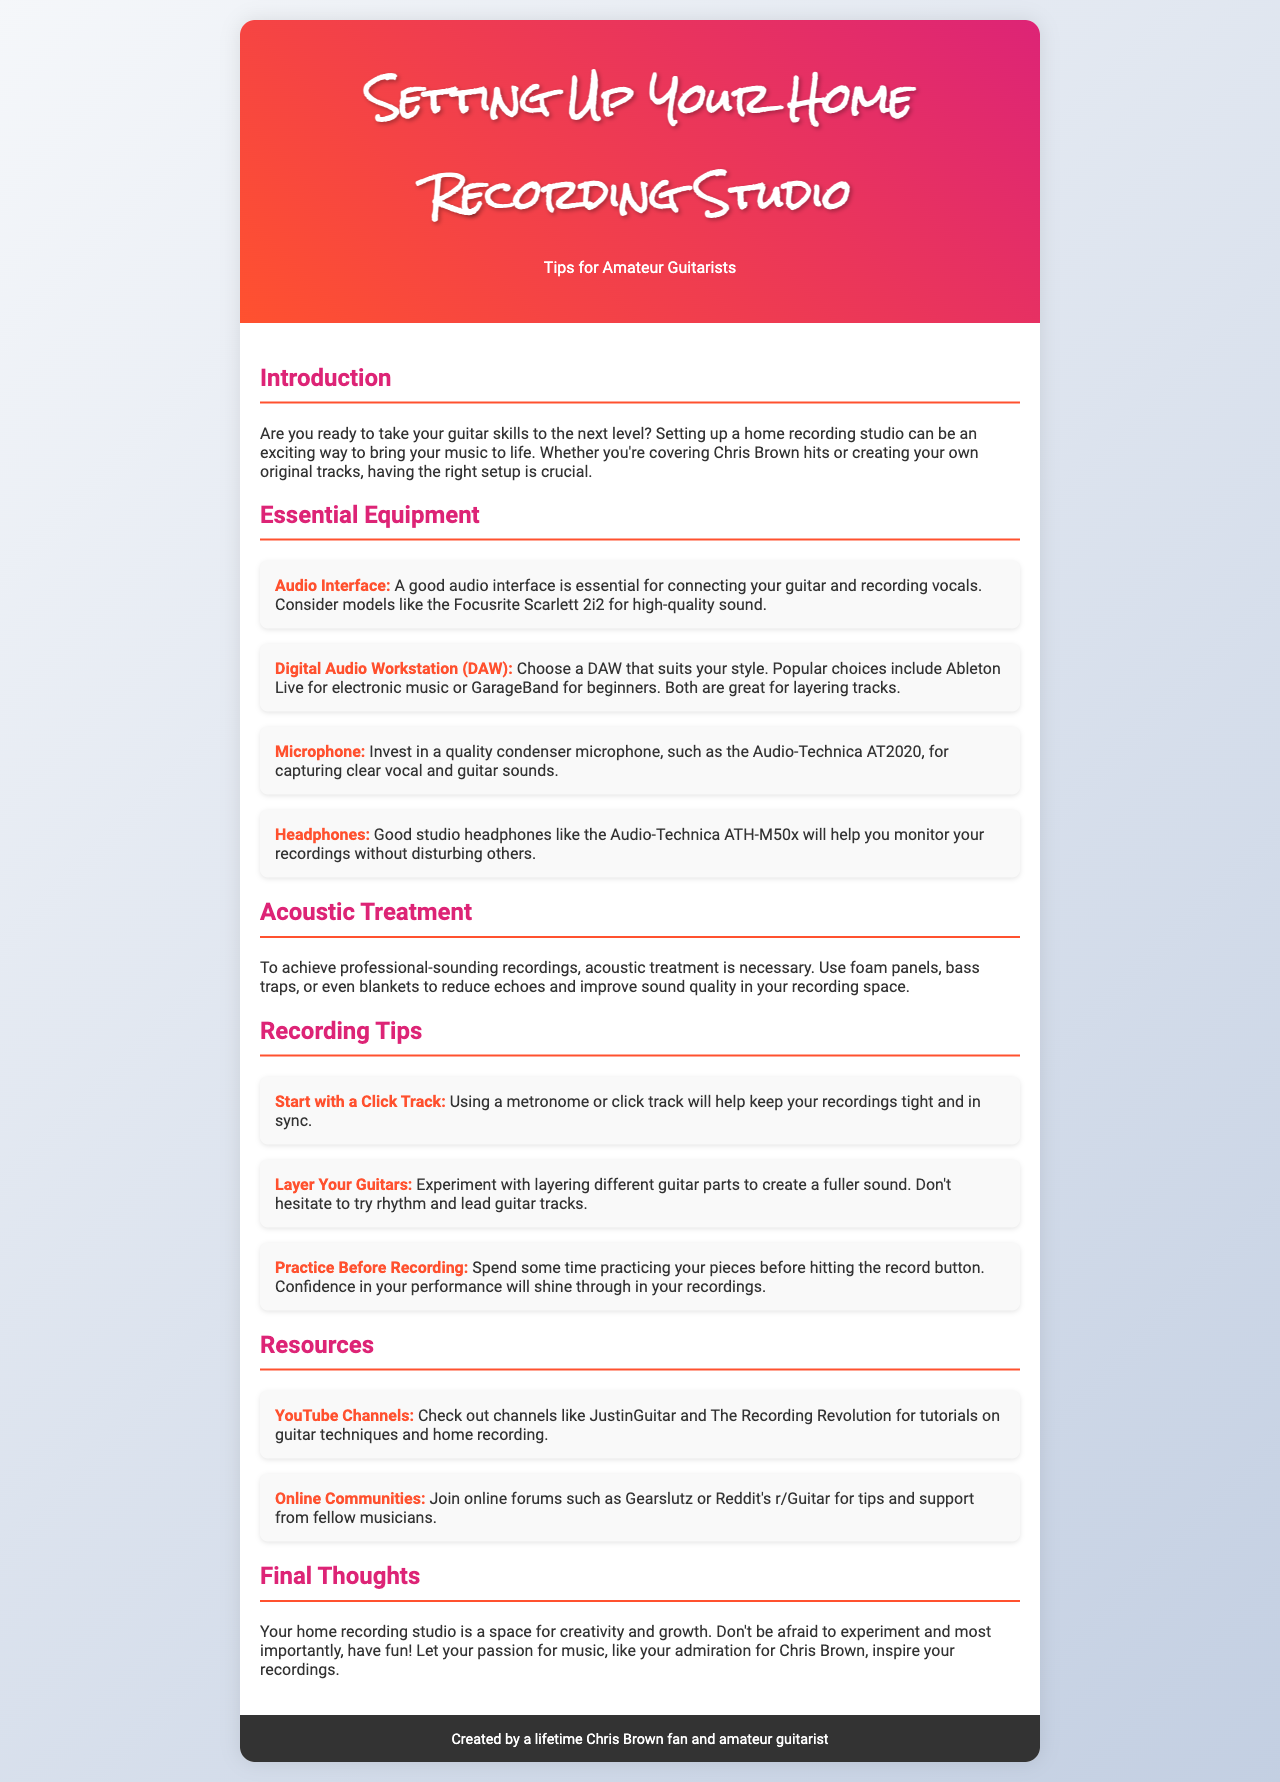What is the main title of the brochure? The main title of the brochure is prominently displayed in the header section.
Answer: Setting Up Your Home Recording Studio Name one audio interface recommended in the document. The document lists specific products under essential equipment.
Answer: Focusrite Scarlett 2i2 What is one example of a resource mentioned for learning? The document provides various resources, including online channels, under the resources section.
Answer: JustinGuitar What is suggested for improving sound quality in recordings? The document discusses acoustic treatment methods to enhance sound quality.
Answer: Foam panels How many recording tips are listed in the document? The document lists several tips under the recording tips section.
Answer: Three Which microphone is recommended in the essential equipment section? The document specifies a microphone choice to ensure good sound capture.
Answer: Audio-Technica AT2020 What kind of headphones are advised for monitoring recordings? The document provides specific headphone models to use in the studio.
Answer: Audio-Technica ATH-M50x What is the suggested practice before recording? The document advises on steps to prepare for a recording session effectively.
Answer: Practice your pieces 